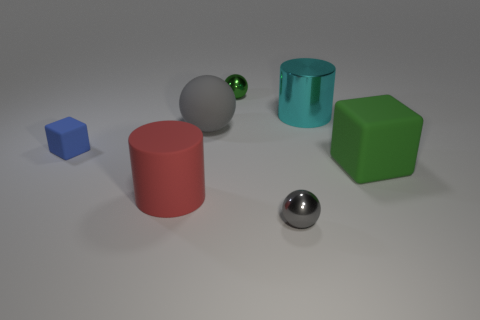Subtract all rubber spheres. How many spheres are left? 2 Subtract all yellow cylinders. How many gray balls are left? 2 Add 1 small brown blocks. How many objects exist? 8 Subtract all red cylinders. How many cylinders are left? 1 Subtract all cubes. How many objects are left? 5 Subtract all small cyan spheres. Subtract all big rubber cubes. How many objects are left? 6 Add 6 large gray matte objects. How many large gray matte objects are left? 7 Add 1 tiny gray metallic objects. How many tiny gray metallic objects exist? 2 Subtract 0 gray cylinders. How many objects are left? 7 Subtract 1 blocks. How many blocks are left? 1 